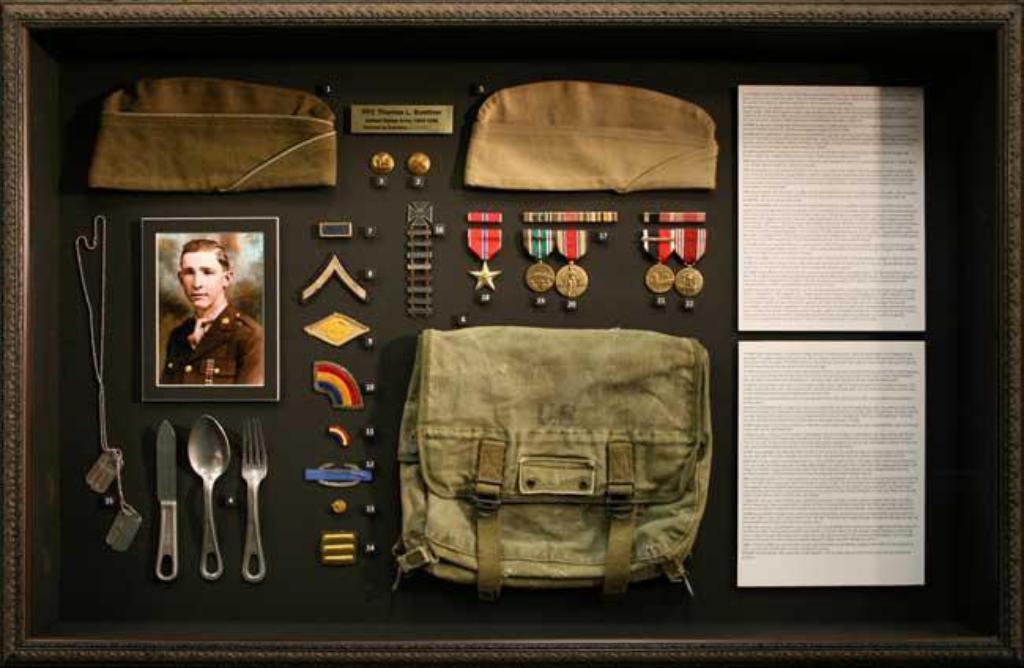Please provide a concise description of this image. In this image we can see a photograph, fork, spoon, knife, chain, badges, bag, caps and papers on the black color surface. 